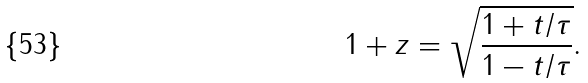<formula> <loc_0><loc_0><loc_500><loc_500>1 + z = \sqrt { \frac { 1 + t / \tau } { 1 - t / \tau } } .</formula> 